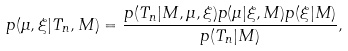<formula> <loc_0><loc_0><loc_500><loc_500>p ( \mu , \xi | T _ { n } , M ) = \frac { p ( T _ { n } | M , \mu , \xi ) p ( \mu | \xi , M ) p ( \xi | M ) } { p ( T _ { n } | M ) } ,</formula> 